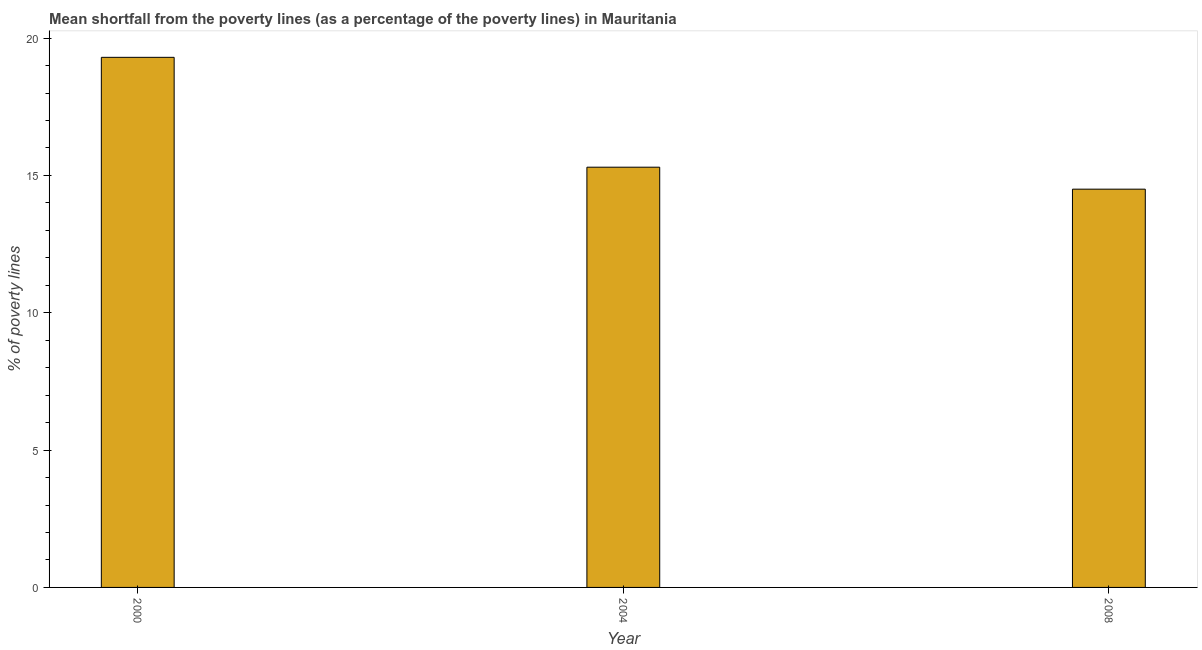What is the title of the graph?
Provide a succinct answer. Mean shortfall from the poverty lines (as a percentage of the poverty lines) in Mauritania. What is the label or title of the Y-axis?
Make the answer very short. % of poverty lines. Across all years, what is the maximum poverty gap at national poverty lines?
Provide a short and direct response. 19.3. Across all years, what is the minimum poverty gap at national poverty lines?
Give a very brief answer. 14.5. What is the sum of the poverty gap at national poverty lines?
Your response must be concise. 49.1. What is the average poverty gap at national poverty lines per year?
Offer a very short reply. 16.37. In how many years, is the poverty gap at national poverty lines greater than 18 %?
Your response must be concise. 1. Do a majority of the years between 2008 and 2004 (inclusive) have poverty gap at national poverty lines greater than 16 %?
Your answer should be compact. No. What is the ratio of the poverty gap at national poverty lines in 2004 to that in 2008?
Offer a terse response. 1.05. Is the poverty gap at national poverty lines in 2000 less than that in 2004?
Offer a terse response. No. Is the difference between the poverty gap at national poverty lines in 2004 and 2008 greater than the difference between any two years?
Provide a succinct answer. No. What is the difference between the highest and the second highest poverty gap at national poverty lines?
Provide a short and direct response. 4. Is the sum of the poverty gap at national poverty lines in 2004 and 2008 greater than the maximum poverty gap at national poverty lines across all years?
Keep it short and to the point. Yes. What is the % of poverty lines of 2000?
Make the answer very short. 19.3. What is the % of poverty lines in 2004?
Provide a succinct answer. 15.3. What is the % of poverty lines of 2008?
Your answer should be compact. 14.5. What is the difference between the % of poverty lines in 2000 and 2004?
Make the answer very short. 4. What is the difference between the % of poverty lines in 2000 and 2008?
Your response must be concise. 4.8. What is the ratio of the % of poverty lines in 2000 to that in 2004?
Your answer should be very brief. 1.26. What is the ratio of the % of poverty lines in 2000 to that in 2008?
Give a very brief answer. 1.33. What is the ratio of the % of poverty lines in 2004 to that in 2008?
Your response must be concise. 1.05. 